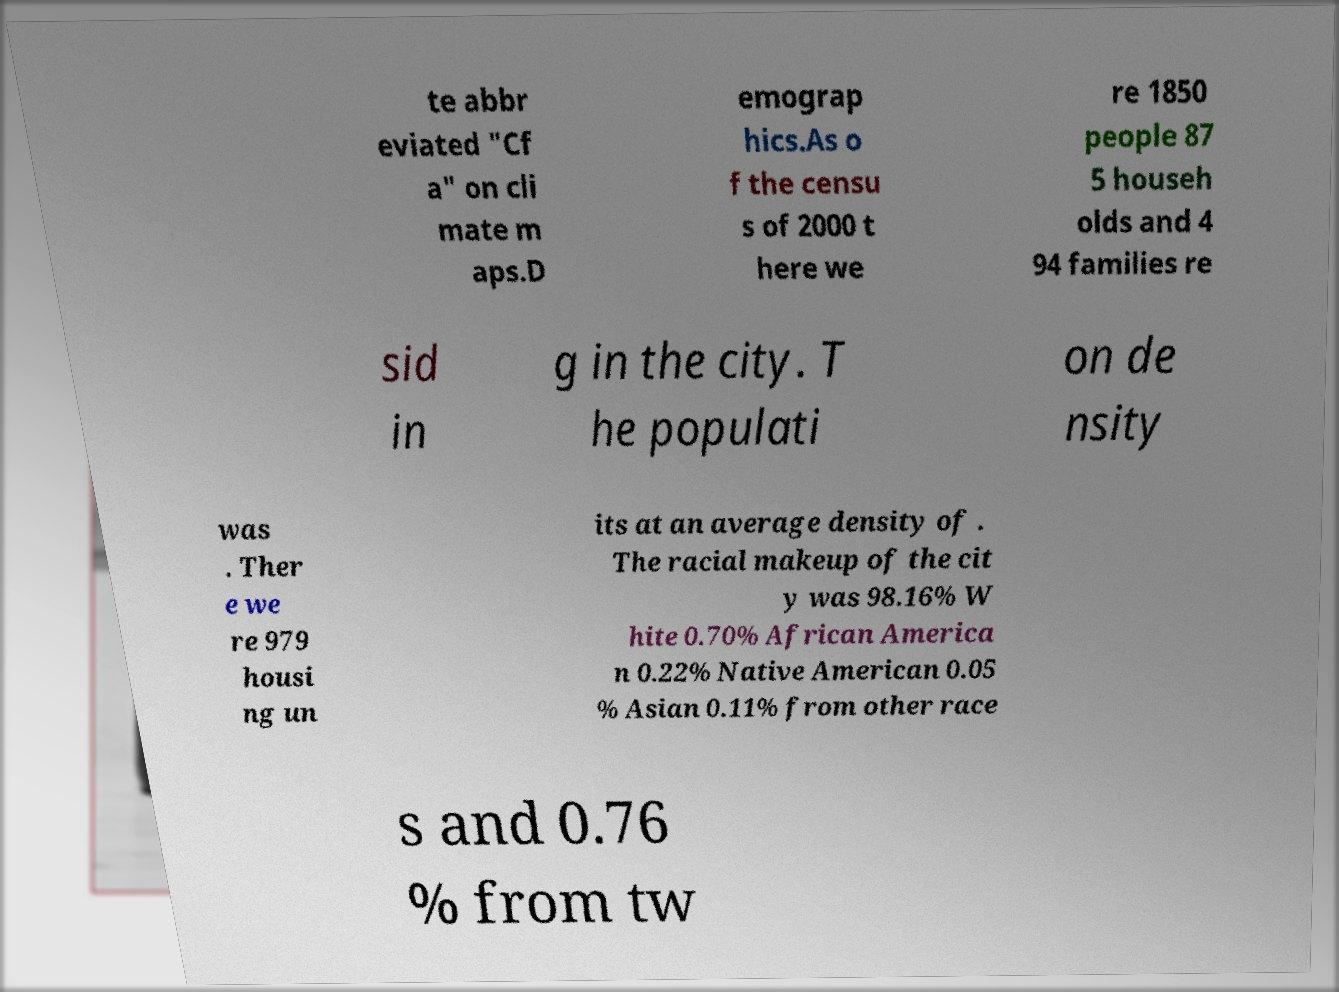Can you read and provide the text displayed in the image?This photo seems to have some interesting text. Can you extract and type it out for me? te abbr eviated "Cf a" on cli mate m aps.D emograp hics.As o f the censu s of 2000 t here we re 1850 people 87 5 househ olds and 4 94 families re sid in g in the city. T he populati on de nsity was . Ther e we re 979 housi ng un its at an average density of . The racial makeup of the cit y was 98.16% W hite 0.70% African America n 0.22% Native American 0.05 % Asian 0.11% from other race s and 0.76 % from tw 